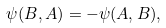<formula> <loc_0><loc_0><loc_500><loc_500>\psi ( B , A ) = - \psi ( A , B ) ,</formula> 